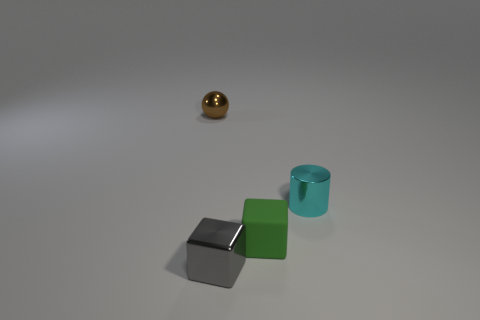Are the gray thing that is in front of the cyan cylinder and the tiny green cube made of the same material?
Provide a short and direct response. No. There is a metallic thing that is behind the cyan metal cylinder; does it have the same size as the cyan metal thing?
Give a very brief answer. Yes. What number of other small cubes have the same color as the rubber block?
Make the answer very short. 0. Is the brown object the same shape as the gray object?
Your answer should be compact. No. Is there anything else that has the same size as the cyan object?
Offer a very short reply. Yes. What is the size of the gray thing that is the same shape as the green matte object?
Make the answer very short. Small. Are there more brown objects on the right side of the small cyan metal object than gray shiny things left of the gray metal block?
Ensure brevity in your answer.  No. Do the gray cube and the small object that is behind the cyan object have the same material?
Your response must be concise. Yes. Is there any other thing that is the same shape as the small brown metal object?
Provide a succinct answer. No. What is the color of the small object that is right of the small brown object and behind the tiny rubber object?
Keep it short and to the point. Cyan. 